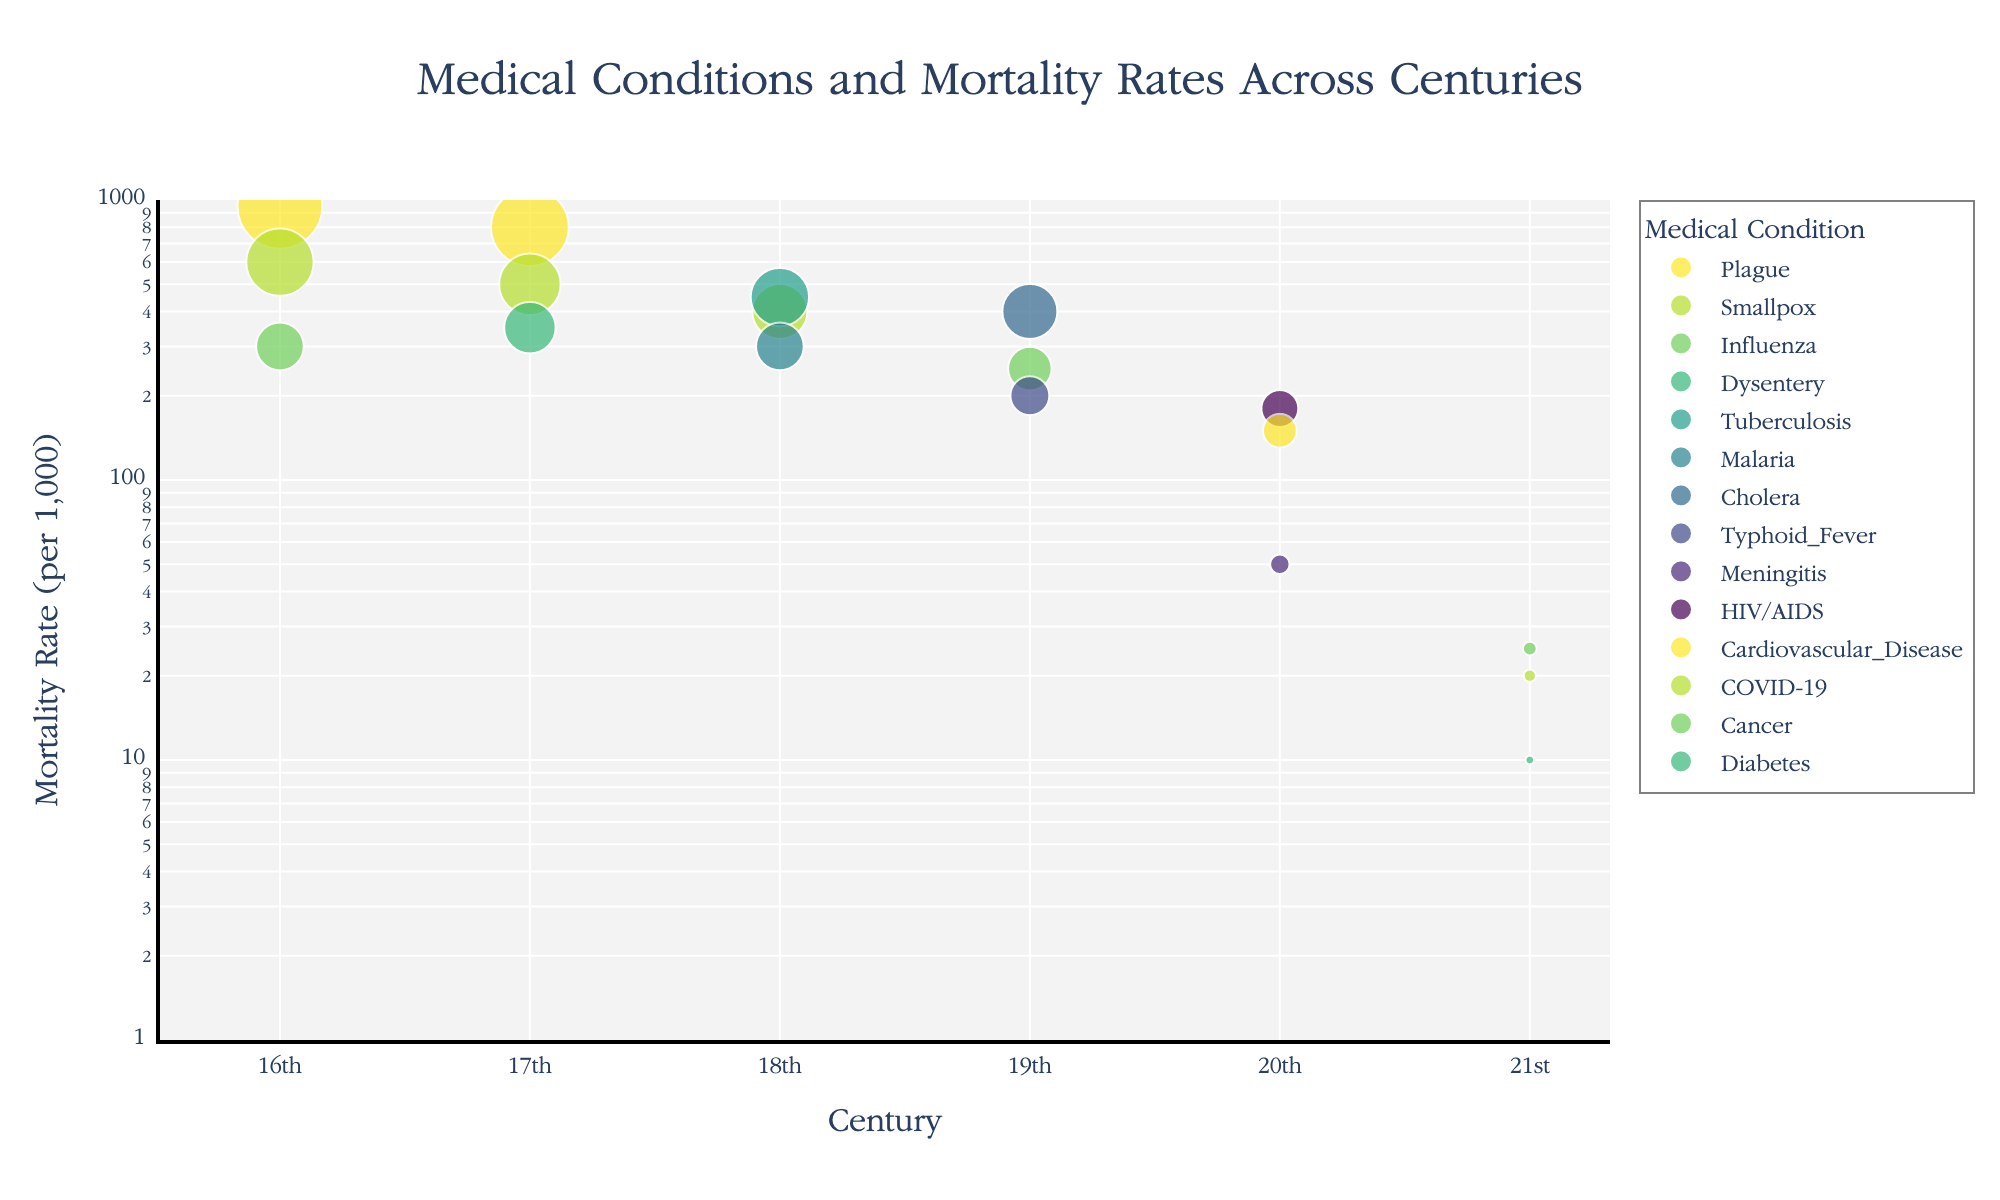What is the title of the scatter plot? The title of the plot is displayed at the top and reads: "Medical Conditions and Mortality Rates Across Centuries". This can be directly observed from the figure.
Answer: Medical Conditions and Mortality Rates Across Centuries Which century shows the highest mortality rate for any medical condition? By inspecting the y-axis (logarithmic scale) and observing the highest point on the plot, we see that the 16th-century point for Plague has the highest mortality rate of 950 per 1000.
Answer: 16th Which medical condition had the lowest mortality rate in the 21st century? By looking at the points in the 21st century on the x-axis and observing the y-axis, Diabetes has the lowest mortality rate of 10 per 1,000.
Answer: Diabetes How does the mortality rate of Smallpox in the 16th century compare to that in the 17th century? In the 16th century, the mortality rate for Smallpox is 600 per 1000, while in the 17th century, it is 500 per 1000, indicating a decrease in the mortality rate over the centuries.
Answer: Decreased Which century shows the medical condition with the smallest mortality rate in the entire dataset? By inspecting the points across all centuries, the 21st-century point for Diabetes has the smallest mortality rate of 10 per 1000.
Answer: 21st How does the mortality rate of Influenza change from the 16th to the 19th century? Influenza had a mortality rate of 300 per 1,000 in the 16th century and 250 per 1,000 in the 19th century, showing a slight decrease.
Answer: Decreased Which medical condition in the 20th century has the highest mortality rate? Looking at the points in the 20th century along the x-axis, HIV/AIDS shows the highest mortality rate of 180 per 1,000.
Answer: HIV/AIDS What is the average mortality rate for the 19th century? The average mortality rate can be calculated by summing the rates for the 19th century (Cholera: 400, Typhoid Fever: 200, Influenza: 250) and dividing by the number of data points: (400 + 200 + 250) / 3 = 850 / 3 ≈ 283.33.
Answer: ≈ 283.33 Which medical condition shows a notable increase in mortality rate going from the 19th to the 20th century? Comparing the medical conditions, none of the conditions in the 19th century appear again in the 20th century. Instead, we look for conditions with the highest rates in the 20th century that may imply an increase if we assume pre-existing lower levels (e.g., Cardiovascular Disease, HIV/AIDS).
Answer: Not directly comparable Is there a general trend in mortality rates from the 16th to the 21st century? Observing the overall distribution, there's a noticeable decrease in mortality rates over the centuries for various medical conditions, demonstrating an overall decline in mortality from the 16th to the 21st century.
Answer: Decreasing 